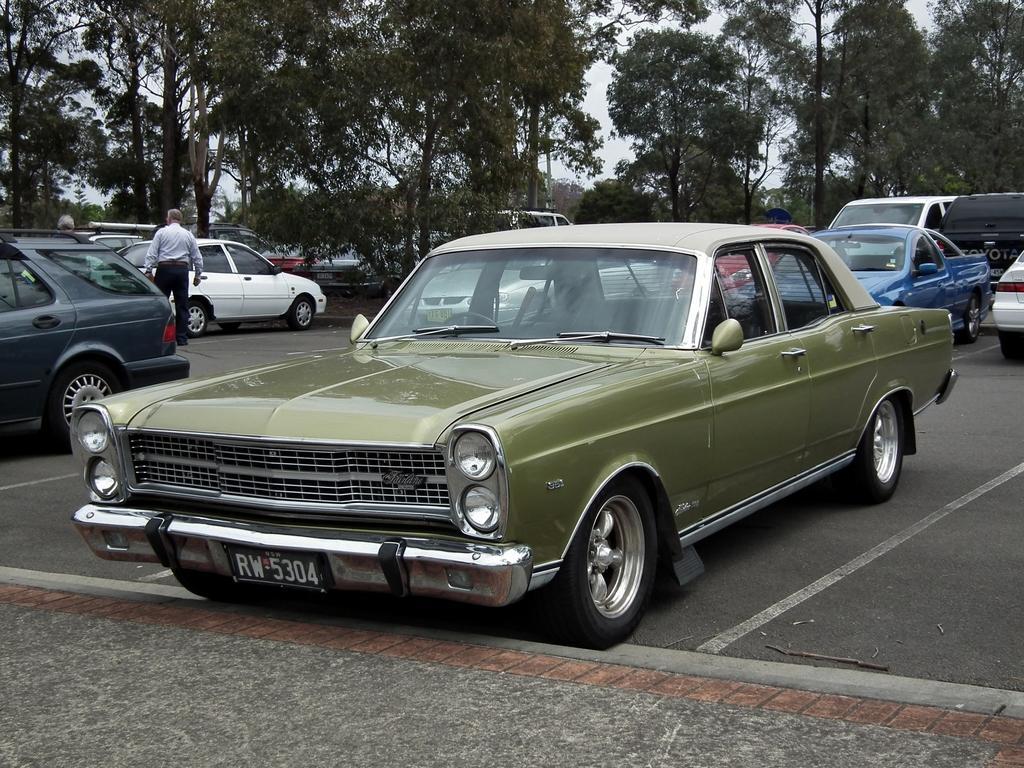Could you give a brief overview of what you see in this image? In this image we can see a few vehicles on the ground, there are some trees and persons, also we can see the sky. 